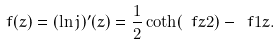<formula> <loc_0><loc_0><loc_500><loc_500>f ( z ) = ( \ln j ) ^ { \prime } ( z ) = \frac { 1 } { 2 } \coth ( \ f { z } { 2 } ) - \ f { 1 } { z } .</formula> 